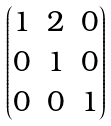<formula> <loc_0><loc_0><loc_500><loc_500>\begin{pmatrix} 1 & 2 & 0 \\ 0 & 1 & 0 \\ 0 & 0 & 1 \end{pmatrix}</formula> 